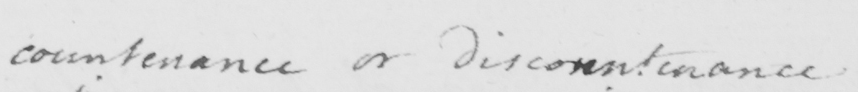Please provide the text content of this handwritten line. countenance or discountenance 